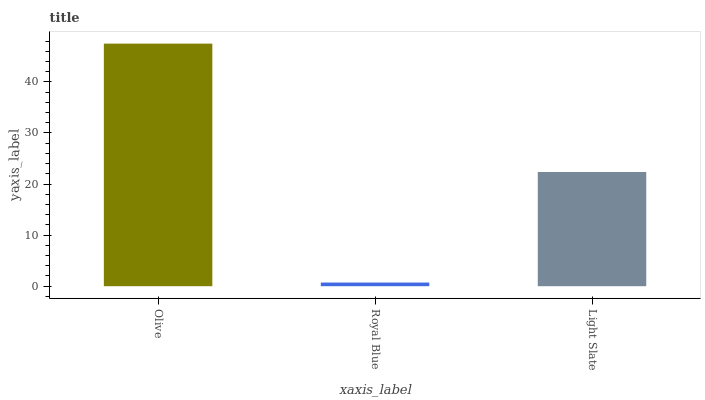Is Light Slate the minimum?
Answer yes or no. No. Is Light Slate the maximum?
Answer yes or no. No. Is Light Slate greater than Royal Blue?
Answer yes or no. Yes. Is Royal Blue less than Light Slate?
Answer yes or no. Yes. Is Royal Blue greater than Light Slate?
Answer yes or no. No. Is Light Slate less than Royal Blue?
Answer yes or no. No. Is Light Slate the high median?
Answer yes or no. Yes. Is Light Slate the low median?
Answer yes or no. Yes. Is Royal Blue the high median?
Answer yes or no. No. Is Royal Blue the low median?
Answer yes or no. No. 